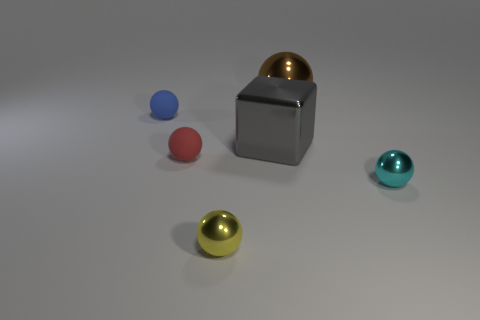What number of objects are spheres that are behind the shiny cube or tiny shiny objects that are behind the small yellow metal sphere?
Your response must be concise. 3. Is the number of brown objects that are on the left side of the tiny yellow metal sphere less than the number of small yellow matte cylinders?
Keep it short and to the point. No. Are there any cyan metal cylinders that have the same size as the red ball?
Your answer should be very brief. No. The large cube is what color?
Your response must be concise. Gray. Is the blue matte object the same size as the cyan shiny sphere?
Keep it short and to the point. Yes. How many things are either large cyan matte blocks or yellow things?
Offer a very short reply. 1. Are there the same number of yellow spheres to the left of the gray thing and large yellow cylinders?
Give a very brief answer. No. There is a small thing on the left side of the red sphere to the left of the small cyan metal sphere; is there a big cube to the right of it?
Keep it short and to the point. Yes. The tiny sphere that is the same material as the small yellow object is what color?
Give a very brief answer. Cyan. What number of blocks are either tiny red objects or big gray metallic things?
Keep it short and to the point. 1. 